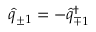<formula> <loc_0><loc_0><loc_500><loc_500>\hat { q } _ { \pm 1 } = - \hat { q } _ { \mp 1 } ^ { \dagger }</formula> 